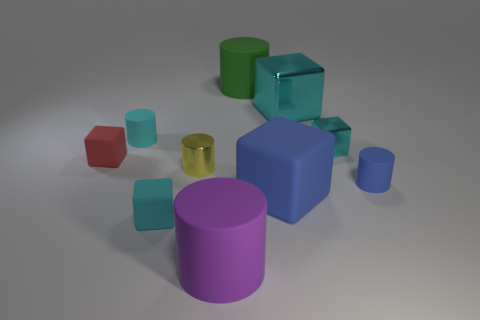Subtract all gray spheres. How many cyan cubes are left? 3 Subtract 1 cubes. How many cubes are left? 4 Subtract all red blocks. How many blocks are left? 4 Subtract all brown blocks. Subtract all brown cylinders. How many blocks are left? 5 Add 3 small cyan matte things. How many small cyan matte things are left? 5 Add 1 purple matte cylinders. How many purple matte cylinders exist? 2 Subtract 2 cyan blocks. How many objects are left? 8 Subtract all small red rubber spheres. Subtract all small cylinders. How many objects are left? 7 